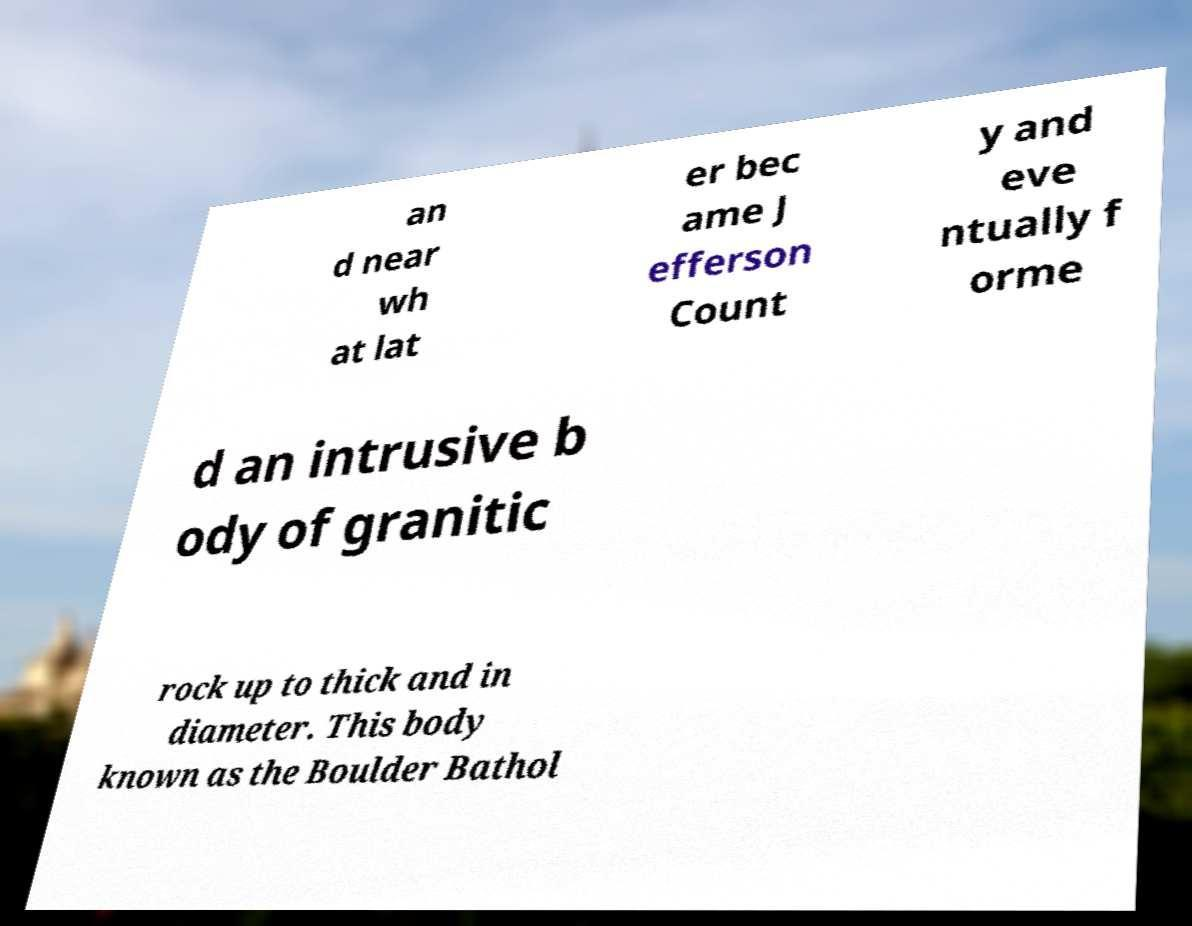Could you extract and type out the text from this image? an d near wh at lat er bec ame J efferson Count y and eve ntually f orme d an intrusive b ody of granitic rock up to thick and in diameter. This body known as the Boulder Bathol 